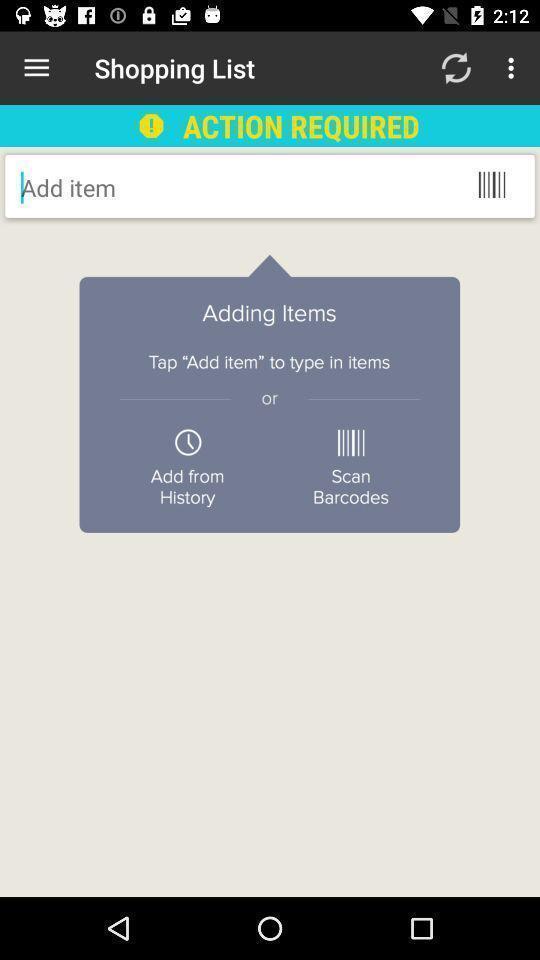Summarize the information in this screenshot. Search box with notification to add items in shopping app. 